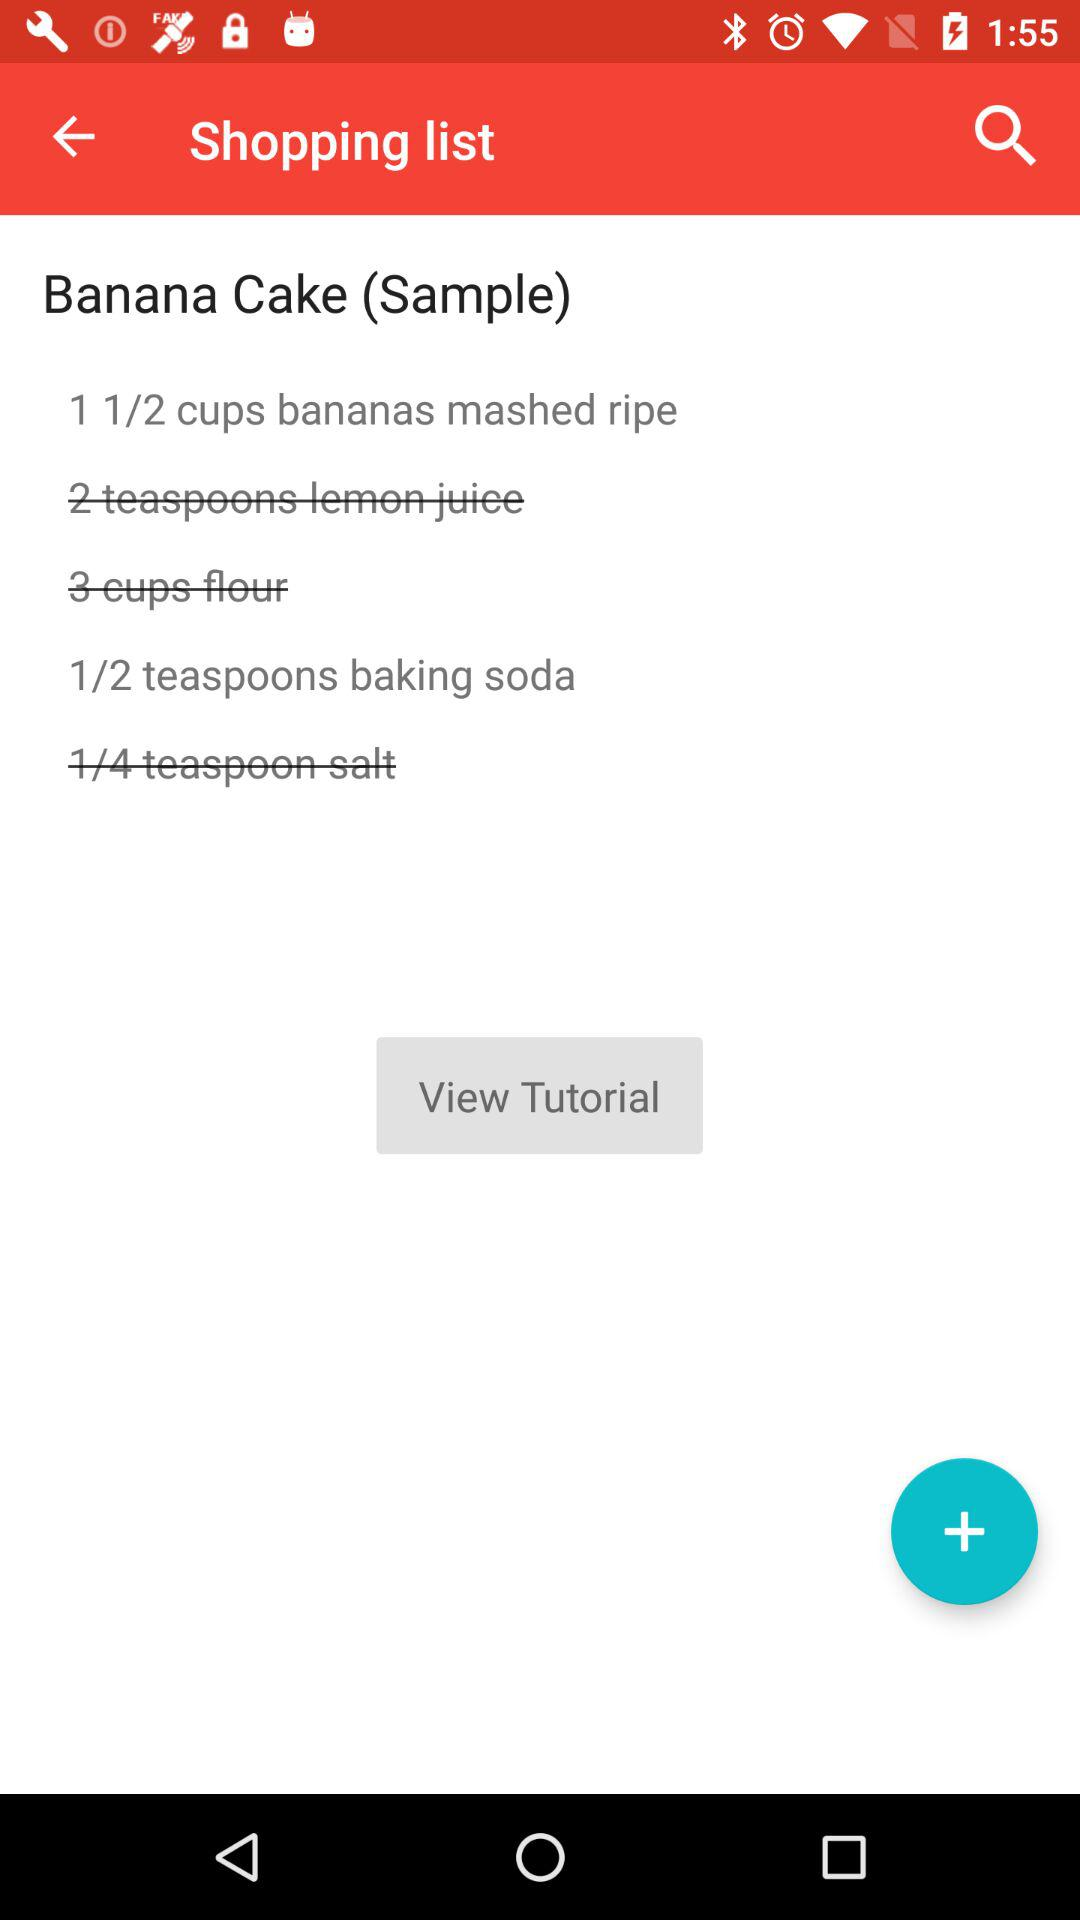What is the sample? The sample is "Banana Cake". 